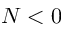<formula> <loc_0><loc_0><loc_500><loc_500>N < 0</formula> 